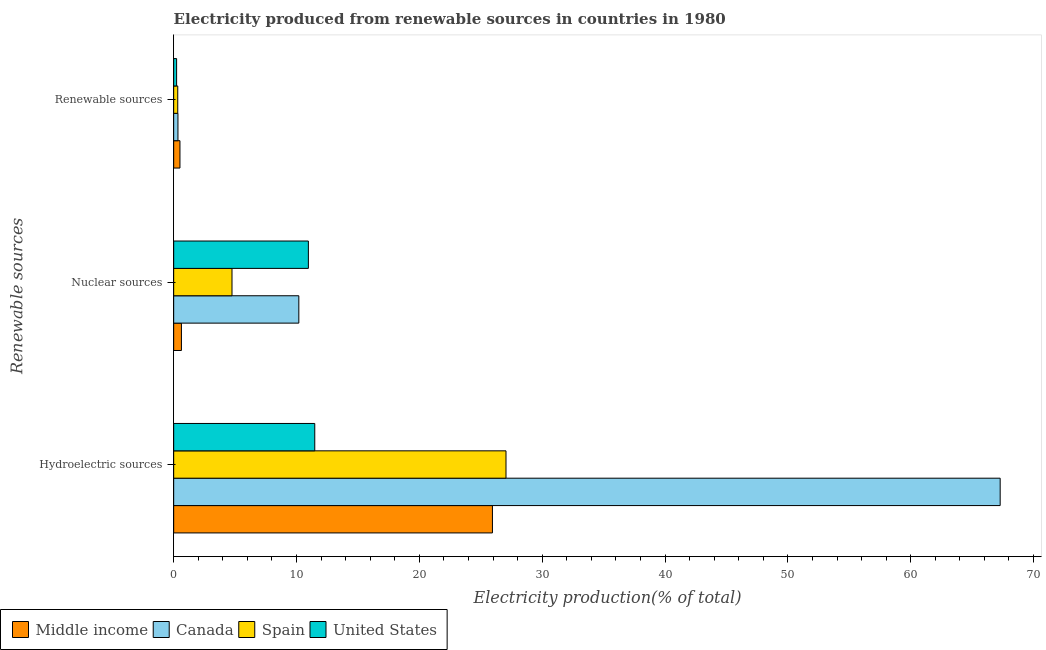Are the number of bars per tick equal to the number of legend labels?
Make the answer very short. Yes. Are the number of bars on each tick of the Y-axis equal?
Keep it short and to the point. Yes. What is the label of the 1st group of bars from the top?
Ensure brevity in your answer.  Renewable sources. What is the percentage of electricity produced by hydroelectric sources in Canada?
Your answer should be compact. 67.28. Across all countries, what is the maximum percentage of electricity produced by renewable sources?
Ensure brevity in your answer.  0.51. Across all countries, what is the minimum percentage of electricity produced by nuclear sources?
Ensure brevity in your answer.  0.63. In which country was the percentage of electricity produced by nuclear sources maximum?
Make the answer very short. United States. What is the total percentage of electricity produced by renewable sources in the graph?
Your answer should be compact. 1.43. What is the difference between the percentage of electricity produced by nuclear sources in Canada and that in Middle income?
Provide a short and direct response. 9.56. What is the difference between the percentage of electricity produced by nuclear sources in Middle income and the percentage of electricity produced by hydroelectric sources in Spain?
Offer a very short reply. -26.42. What is the average percentage of electricity produced by nuclear sources per country?
Your response must be concise. 6.63. What is the difference between the percentage of electricity produced by renewable sources and percentage of electricity produced by hydroelectric sources in Canada?
Offer a terse response. -66.93. In how many countries, is the percentage of electricity produced by nuclear sources greater than 10 %?
Provide a succinct answer. 2. What is the ratio of the percentage of electricity produced by hydroelectric sources in Spain to that in Middle income?
Your response must be concise. 1.04. Is the percentage of electricity produced by nuclear sources in Spain less than that in Middle income?
Keep it short and to the point. No. What is the difference between the highest and the second highest percentage of electricity produced by nuclear sources?
Offer a very short reply. 0.78. What is the difference between the highest and the lowest percentage of electricity produced by nuclear sources?
Ensure brevity in your answer.  10.34. In how many countries, is the percentage of electricity produced by renewable sources greater than the average percentage of electricity produced by renewable sources taken over all countries?
Provide a short and direct response. 1. Is the sum of the percentage of electricity produced by renewable sources in United States and Spain greater than the maximum percentage of electricity produced by hydroelectric sources across all countries?
Your answer should be very brief. No. What does the 2nd bar from the top in Renewable sources represents?
Provide a succinct answer. Spain. Is it the case that in every country, the sum of the percentage of electricity produced by hydroelectric sources and percentage of electricity produced by nuclear sources is greater than the percentage of electricity produced by renewable sources?
Ensure brevity in your answer.  Yes. How many bars are there?
Provide a short and direct response. 12. Are all the bars in the graph horizontal?
Offer a very short reply. Yes. What is the difference between two consecutive major ticks on the X-axis?
Make the answer very short. 10. Does the graph contain any zero values?
Make the answer very short. No. How are the legend labels stacked?
Offer a very short reply. Horizontal. What is the title of the graph?
Give a very brief answer. Electricity produced from renewable sources in countries in 1980. Does "South Asia" appear as one of the legend labels in the graph?
Ensure brevity in your answer.  No. What is the label or title of the X-axis?
Keep it short and to the point. Electricity production(% of total). What is the label or title of the Y-axis?
Ensure brevity in your answer.  Renewable sources. What is the Electricity production(% of total) of Middle income in Hydroelectric sources?
Provide a succinct answer. 25.95. What is the Electricity production(% of total) of Canada in Hydroelectric sources?
Offer a terse response. 67.28. What is the Electricity production(% of total) in Spain in Hydroelectric sources?
Offer a very short reply. 27.05. What is the Electricity production(% of total) of United States in Hydroelectric sources?
Your answer should be very brief. 11.49. What is the Electricity production(% of total) of Middle income in Nuclear sources?
Your answer should be very brief. 0.63. What is the Electricity production(% of total) in Canada in Nuclear sources?
Keep it short and to the point. 10.19. What is the Electricity production(% of total) of Spain in Nuclear sources?
Ensure brevity in your answer.  4.75. What is the Electricity production(% of total) in United States in Nuclear sources?
Provide a short and direct response. 10.97. What is the Electricity production(% of total) in Middle income in Renewable sources?
Give a very brief answer. 0.51. What is the Electricity production(% of total) in Canada in Renewable sources?
Offer a very short reply. 0.35. What is the Electricity production(% of total) of Spain in Renewable sources?
Provide a short and direct response. 0.33. What is the Electricity production(% of total) of United States in Renewable sources?
Your response must be concise. 0.24. Across all Renewable sources, what is the maximum Electricity production(% of total) of Middle income?
Your answer should be compact. 25.95. Across all Renewable sources, what is the maximum Electricity production(% of total) of Canada?
Provide a short and direct response. 67.28. Across all Renewable sources, what is the maximum Electricity production(% of total) in Spain?
Your answer should be compact. 27.05. Across all Renewable sources, what is the maximum Electricity production(% of total) of United States?
Make the answer very short. 11.49. Across all Renewable sources, what is the minimum Electricity production(% of total) in Middle income?
Give a very brief answer. 0.51. Across all Renewable sources, what is the minimum Electricity production(% of total) in Canada?
Your response must be concise. 0.35. Across all Renewable sources, what is the minimum Electricity production(% of total) of Spain?
Provide a succinct answer. 0.33. Across all Renewable sources, what is the minimum Electricity production(% of total) in United States?
Your response must be concise. 0.24. What is the total Electricity production(% of total) in Middle income in the graph?
Your answer should be compact. 27.09. What is the total Electricity production(% of total) in Canada in the graph?
Provide a short and direct response. 77.82. What is the total Electricity production(% of total) of Spain in the graph?
Your answer should be very brief. 32.13. What is the total Electricity production(% of total) in United States in the graph?
Make the answer very short. 22.69. What is the difference between the Electricity production(% of total) in Middle income in Hydroelectric sources and that in Nuclear sources?
Provide a short and direct response. 25.32. What is the difference between the Electricity production(% of total) in Canada in Hydroelectric sources and that in Nuclear sources?
Keep it short and to the point. 57.09. What is the difference between the Electricity production(% of total) of Spain in Hydroelectric sources and that in Nuclear sources?
Provide a short and direct response. 22.31. What is the difference between the Electricity production(% of total) of United States in Hydroelectric sources and that in Nuclear sources?
Your answer should be very brief. 0.52. What is the difference between the Electricity production(% of total) of Middle income in Hydroelectric sources and that in Renewable sources?
Make the answer very short. 25.44. What is the difference between the Electricity production(% of total) in Canada in Hydroelectric sources and that in Renewable sources?
Your answer should be very brief. 66.93. What is the difference between the Electricity production(% of total) of Spain in Hydroelectric sources and that in Renewable sources?
Your response must be concise. 26.72. What is the difference between the Electricity production(% of total) in United States in Hydroelectric sources and that in Renewable sources?
Provide a succinct answer. 11.25. What is the difference between the Electricity production(% of total) of Middle income in Nuclear sources and that in Renewable sources?
Provide a short and direct response. 0.12. What is the difference between the Electricity production(% of total) of Canada in Nuclear sources and that in Renewable sources?
Give a very brief answer. 9.84. What is the difference between the Electricity production(% of total) in Spain in Nuclear sources and that in Renewable sources?
Offer a very short reply. 4.42. What is the difference between the Electricity production(% of total) of United States in Nuclear sources and that in Renewable sources?
Offer a very short reply. 10.73. What is the difference between the Electricity production(% of total) of Middle income in Hydroelectric sources and the Electricity production(% of total) of Canada in Nuclear sources?
Your answer should be compact. 15.76. What is the difference between the Electricity production(% of total) of Middle income in Hydroelectric sources and the Electricity production(% of total) of Spain in Nuclear sources?
Offer a terse response. 21.2. What is the difference between the Electricity production(% of total) in Middle income in Hydroelectric sources and the Electricity production(% of total) in United States in Nuclear sources?
Your answer should be very brief. 14.98. What is the difference between the Electricity production(% of total) of Canada in Hydroelectric sources and the Electricity production(% of total) of Spain in Nuclear sources?
Your answer should be very brief. 62.53. What is the difference between the Electricity production(% of total) of Canada in Hydroelectric sources and the Electricity production(% of total) of United States in Nuclear sources?
Ensure brevity in your answer.  56.32. What is the difference between the Electricity production(% of total) in Spain in Hydroelectric sources and the Electricity production(% of total) in United States in Nuclear sources?
Your response must be concise. 16.09. What is the difference between the Electricity production(% of total) of Middle income in Hydroelectric sources and the Electricity production(% of total) of Canada in Renewable sources?
Your response must be concise. 25.6. What is the difference between the Electricity production(% of total) of Middle income in Hydroelectric sources and the Electricity production(% of total) of Spain in Renewable sources?
Ensure brevity in your answer.  25.62. What is the difference between the Electricity production(% of total) in Middle income in Hydroelectric sources and the Electricity production(% of total) in United States in Renewable sources?
Your answer should be very brief. 25.71. What is the difference between the Electricity production(% of total) of Canada in Hydroelectric sources and the Electricity production(% of total) of Spain in Renewable sources?
Make the answer very short. 66.95. What is the difference between the Electricity production(% of total) of Canada in Hydroelectric sources and the Electricity production(% of total) of United States in Renewable sources?
Give a very brief answer. 67.04. What is the difference between the Electricity production(% of total) in Spain in Hydroelectric sources and the Electricity production(% of total) in United States in Renewable sources?
Provide a short and direct response. 26.81. What is the difference between the Electricity production(% of total) of Middle income in Nuclear sources and the Electricity production(% of total) of Canada in Renewable sources?
Your response must be concise. 0.28. What is the difference between the Electricity production(% of total) in Middle income in Nuclear sources and the Electricity production(% of total) in Spain in Renewable sources?
Ensure brevity in your answer.  0.3. What is the difference between the Electricity production(% of total) in Middle income in Nuclear sources and the Electricity production(% of total) in United States in Renewable sources?
Ensure brevity in your answer.  0.39. What is the difference between the Electricity production(% of total) in Canada in Nuclear sources and the Electricity production(% of total) in Spain in Renewable sources?
Ensure brevity in your answer.  9.86. What is the difference between the Electricity production(% of total) of Canada in Nuclear sources and the Electricity production(% of total) of United States in Renewable sources?
Provide a succinct answer. 9.95. What is the difference between the Electricity production(% of total) of Spain in Nuclear sources and the Electricity production(% of total) of United States in Renewable sources?
Offer a terse response. 4.51. What is the average Electricity production(% of total) of Middle income per Renewable sources?
Make the answer very short. 9.03. What is the average Electricity production(% of total) of Canada per Renewable sources?
Offer a very short reply. 25.94. What is the average Electricity production(% of total) of Spain per Renewable sources?
Give a very brief answer. 10.71. What is the average Electricity production(% of total) of United States per Renewable sources?
Keep it short and to the point. 7.56. What is the difference between the Electricity production(% of total) of Middle income and Electricity production(% of total) of Canada in Hydroelectric sources?
Provide a short and direct response. -41.33. What is the difference between the Electricity production(% of total) in Middle income and Electricity production(% of total) in Spain in Hydroelectric sources?
Keep it short and to the point. -1.1. What is the difference between the Electricity production(% of total) of Middle income and Electricity production(% of total) of United States in Hydroelectric sources?
Provide a succinct answer. 14.46. What is the difference between the Electricity production(% of total) of Canada and Electricity production(% of total) of Spain in Hydroelectric sources?
Provide a short and direct response. 40.23. What is the difference between the Electricity production(% of total) of Canada and Electricity production(% of total) of United States in Hydroelectric sources?
Give a very brief answer. 55.8. What is the difference between the Electricity production(% of total) in Spain and Electricity production(% of total) in United States in Hydroelectric sources?
Your answer should be compact. 15.57. What is the difference between the Electricity production(% of total) in Middle income and Electricity production(% of total) in Canada in Nuclear sources?
Keep it short and to the point. -9.56. What is the difference between the Electricity production(% of total) in Middle income and Electricity production(% of total) in Spain in Nuclear sources?
Make the answer very short. -4.12. What is the difference between the Electricity production(% of total) in Middle income and Electricity production(% of total) in United States in Nuclear sources?
Provide a succinct answer. -10.34. What is the difference between the Electricity production(% of total) of Canada and Electricity production(% of total) of Spain in Nuclear sources?
Provide a short and direct response. 5.44. What is the difference between the Electricity production(% of total) of Canada and Electricity production(% of total) of United States in Nuclear sources?
Keep it short and to the point. -0.78. What is the difference between the Electricity production(% of total) in Spain and Electricity production(% of total) in United States in Nuclear sources?
Your response must be concise. -6.22. What is the difference between the Electricity production(% of total) in Middle income and Electricity production(% of total) in Canada in Renewable sources?
Give a very brief answer. 0.16. What is the difference between the Electricity production(% of total) of Middle income and Electricity production(% of total) of Spain in Renewable sources?
Your answer should be compact. 0.18. What is the difference between the Electricity production(% of total) of Middle income and Electricity production(% of total) of United States in Renewable sources?
Your answer should be very brief. 0.27. What is the difference between the Electricity production(% of total) in Canada and Electricity production(% of total) in Spain in Renewable sources?
Offer a terse response. 0.02. What is the difference between the Electricity production(% of total) of Canada and Electricity production(% of total) of United States in Renewable sources?
Ensure brevity in your answer.  0.11. What is the difference between the Electricity production(% of total) of Spain and Electricity production(% of total) of United States in Renewable sources?
Your answer should be compact. 0.09. What is the ratio of the Electricity production(% of total) of Middle income in Hydroelectric sources to that in Nuclear sources?
Provide a short and direct response. 41.12. What is the ratio of the Electricity production(% of total) in Canada in Hydroelectric sources to that in Nuclear sources?
Keep it short and to the point. 6.6. What is the ratio of the Electricity production(% of total) in Spain in Hydroelectric sources to that in Nuclear sources?
Provide a succinct answer. 5.7. What is the ratio of the Electricity production(% of total) in United States in Hydroelectric sources to that in Nuclear sources?
Offer a terse response. 1.05. What is the ratio of the Electricity production(% of total) in Middle income in Hydroelectric sources to that in Renewable sources?
Keep it short and to the point. 50.74. What is the ratio of the Electricity production(% of total) of Canada in Hydroelectric sources to that in Renewable sources?
Keep it short and to the point. 193.19. What is the ratio of the Electricity production(% of total) of Spain in Hydroelectric sources to that in Renewable sources?
Make the answer very short. 81.63. What is the ratio of the Electricity production(% of total) of United States in Hydroelectric sources to that in Renewable sources?
Provide a short and direct response. 47.99. What is the ratio of the Electricity production(% of total) in Middle income in Nuclear sources to that in Renewable sources?
Provide a short and direct response. 1.23. What is the ratio of the Electricity production(% of total) of Canada in Nuclear sources to that in Renewable sources?
Your answer should be compact. 29.26. What is the ratio of the Electricity production(% of total) of Spain in Nuclear sources to that in Renewable sources?
Your answer should be very brief. 14.33. What is the ratio of the Electricity production(% of total) of United States in Nuclear sources to that in Renewable sources?
Offer a very short reply. 45.82. What is the difference between the highest and the second highest Electricity production(% of total) in Middle income?
Offer a very short reply. 25.32. What is the difference between the highest and the second highest Electricity production(% of total) of Canada?
Ensure brevity in your answer.  57.09. What is the difference between the highest and the second highest Electricity production(% of total) of Spain?
Keep it short and to the point. 22.31. What is the difference between the highest and the second highest Electricity production(% of total) of United States?
Your response must be concise. 0.52. What is the difference between the highest and the lowest Electricity production(% of total) of Middle income?
Offer a terse response. 25.44. What is the difference between the highest and the lowest Electricity production(% of total) in Canada?
Offer a very short reply. 66.93. What is the difference between the highest and the lowest Electricity production(% of total) in Spain?
Make the answer very short. 26.72. What is the difference between the highest and the lowest Electricity production(% of total) in United States?
Offer a very short reply. 11.25. 